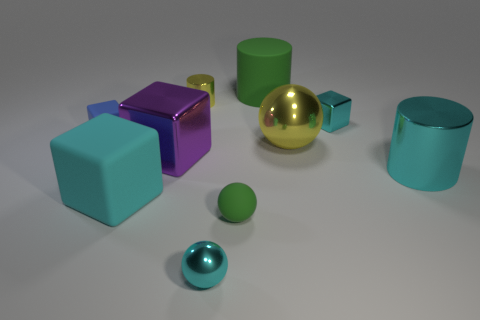Is the shape of the large purple metal object the same as the large yellow metallic thing?
Keep it short and to the point. No. Does the shiny ball that is on the left side of the large green cylinder have the same color as the matte sphere?
Your response must be concise. No. How many objects are either big green matte cylinders or large matte objects on the left side of the big purple object?
Your answer should be compact. 2. The cyan object that is in front of the cyan cylinder and behind the small green object is made of what material?
Provide a short and direct response. Rubber. There is a cyan block in front of the cyan cylinder; what material is it?
Give a very brief answer. Rubber. What color is the other ball that is made of the same material as the cyan sphere?
Your response must be concise. Yellow. There is a blue rubber thing; is its shape the same as the yellow metallic object that is in front of the small blue matte block?
Give a very brief answer. No. Are there any cyan things behind the tiny rubber block?
Ensure brevity in your answer.  Yes. There is a thing that is the same color as the tiny cylinder; what is its material?
Provide a succinct answer. Metal. Do the cyan matte block and the metal cylinder that is to the left of the yellow sphere have the same size?
Provide a short and direct response. No. 